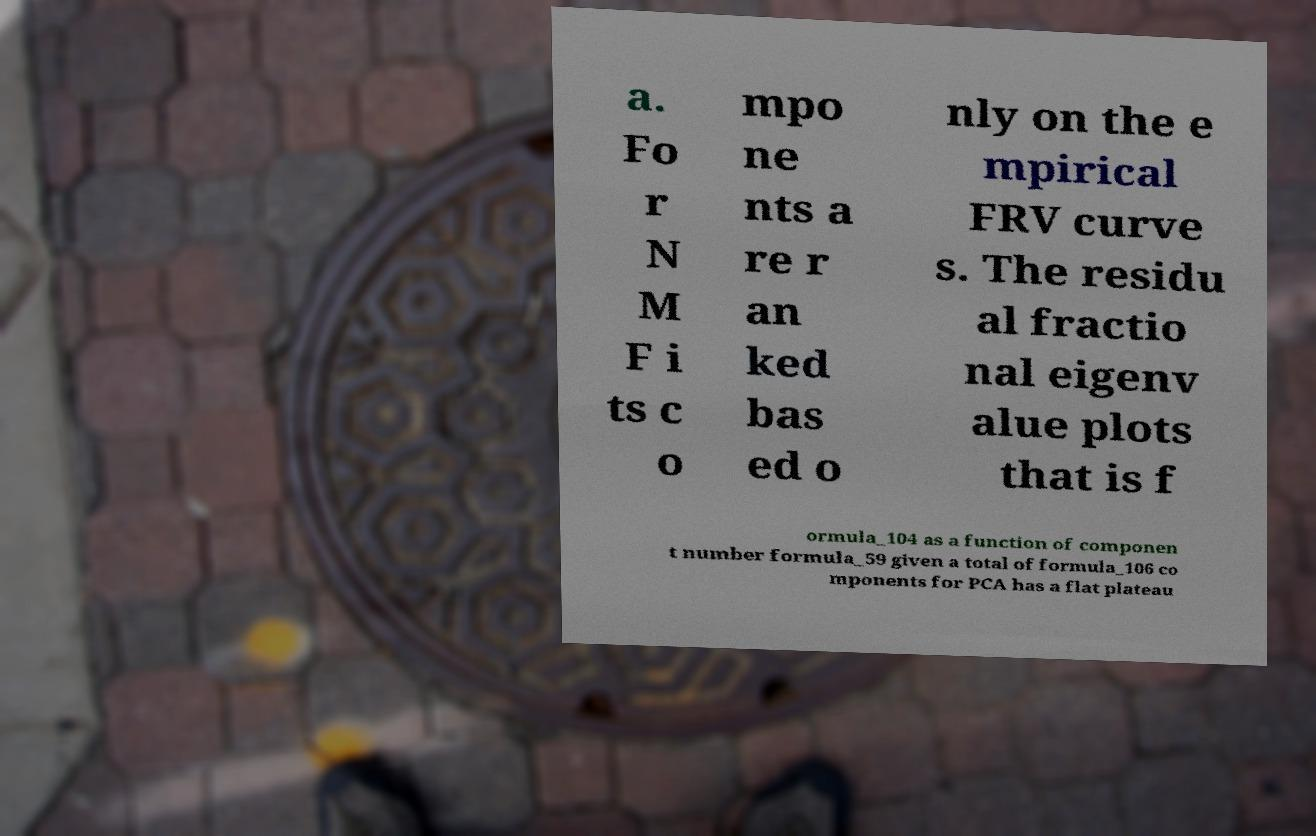For documentation purposes, I need the text within this image transcribed. Could you provide that? a. Fo r N M F i ts c o mpo ne nts a re r an ked bas ed o nly on the e mpirical FRV curve s. The residu al fractio nal eigenv alue plots that is f ormula_104 as a function of componen t number formula_59 given a total of formula_106 co mponents for PCA has a flat plateau 